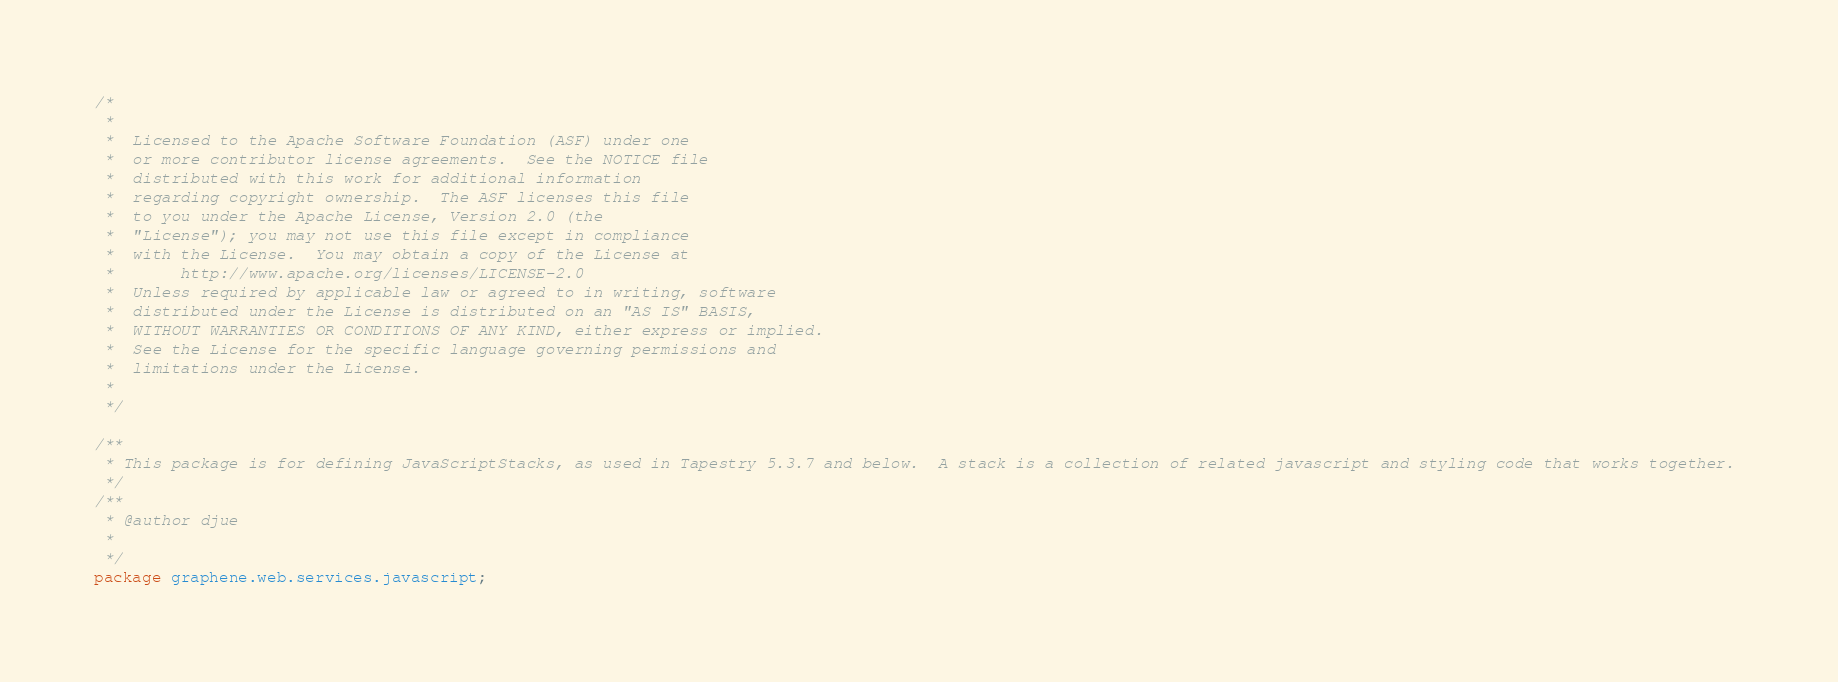<code> <loc_0><loc_0><loc_500><loc_500><_Java_>/*
 *
 *  Licensed to the Apache Software Foundation (ASF) under one
 *  or more contributor license agreements.  See the NOTICE file
 *  distributed with this work for additional information
 *  regarding copyright ownership.  The ASF licenses this file
 *  to you under the Apache License, Version 2.0 (the
 *  "License"); you may not use this file except in compliance
 *  with the License.  You may obtain a copy of the License at
 *       http://www.apache.org/licenses/LICENSE-2.0
 *  Unless required by applicable law or agreed to in writing, software
 *  distributed under the License is distributed on an "AS IS" BASIS,
 *  WITHOUT WARRANTIES OR CONDITIONS OF ANY KIND, either express or implied.
 *  See the License for the specific language governing permissions and
 *  limitations under the License.
 *
 */

/**
 * This package is for defining JavaScriptStacks, as used in Tapestry 5.3.7 and below.  A stack is a collection of related javascript and styling code that works together. 
 */
/**
 * @author djue
 *
 */
package graphene.web.services.javascript;</code> 